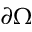Convert formula to latex. <formula><loc_0><loc_0><loc_500><loc_500>\partial \Omega</formula> 